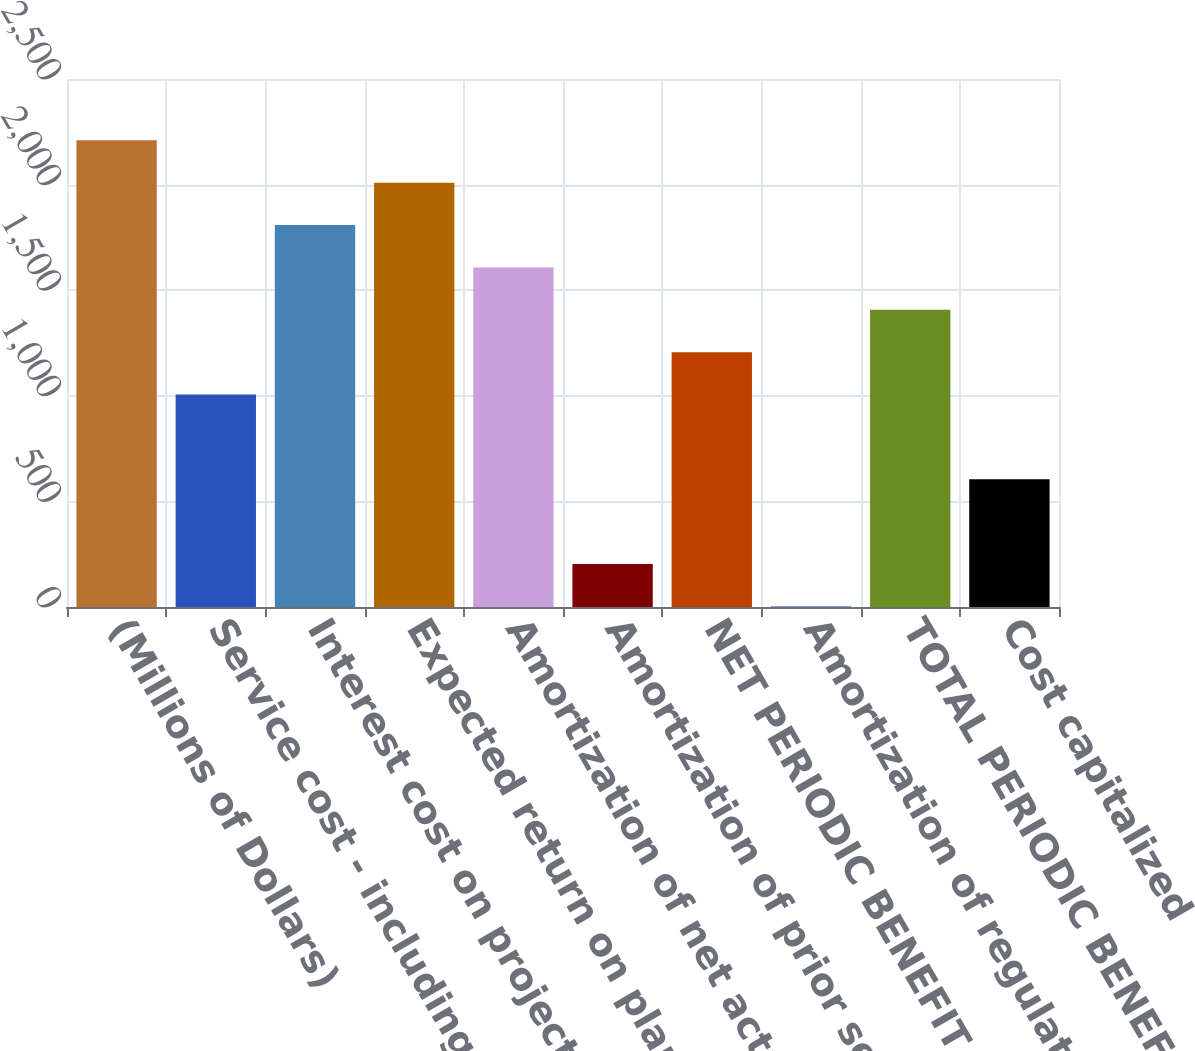Convert chart to OTSL. <chart><loc_0><loc_0><loc_500><loc_500><bar_chart><fcel>(Millions of Dollars)<fcel>Service cost - including<fcel>Interest cost on projected<fcel>Expected return on plan assets<fcel>Amortization of net actuarial<fcel>Amortization of prior service<fcel>NET PERIODIC BENEFIT COST<fcel>Amortization of regulatory<fcel>TOTAL PERIODIC BENEFIT COST<fcel>Cost capitalized<nl><fcel>2209.6<fcel>1006<fcel>1808.4<fcel>2009<fcel>1607.8<fcel>203.6<fcel>1206.6<fcel>3<fcel>1407.2<fcel>604.8<nl></chart> 